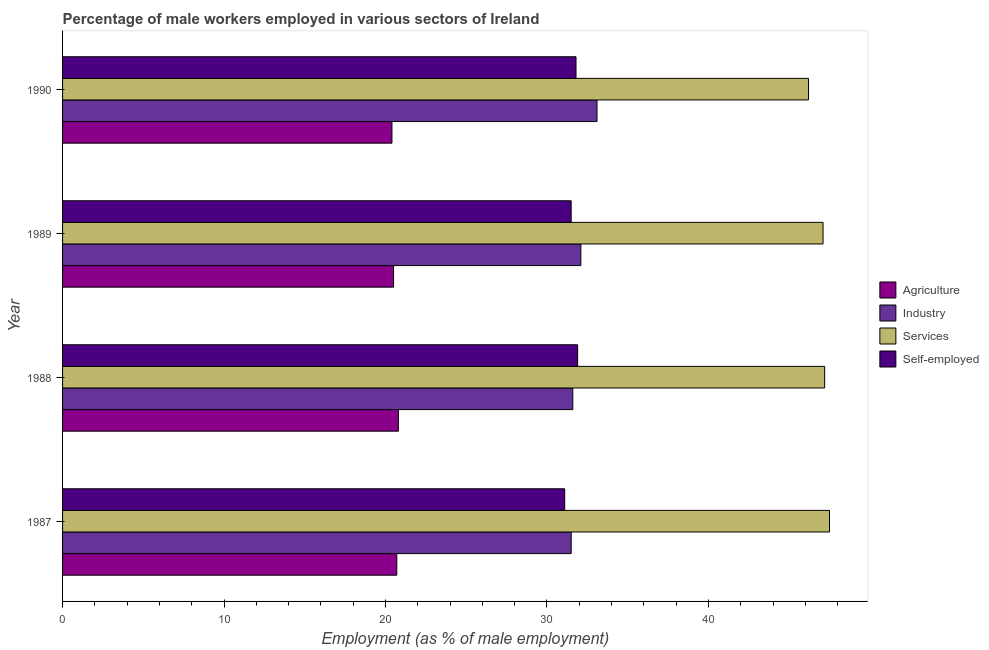How many different coloured bars are there?
Ensure brevity in your answer.  4. How many groups of bars are there?
Your answer should be very brief. 4. Are the number of bars per tick equal to the number of legend labels?
Your answer should be very brief. Yes. Are the number of bars on each tick of the Y-axis equal?
Keep it short and to the point. Yes. How many bars are there on the 3rd tick from the top?
Provide a succinct answer. 4. How many bars are there on the 4th tick from the bottom?
Your response must be concise. 4. What is the percentage of male workers in industry in 1988?
Keep it short and to the point. 31.6. Across all years, what is the maximum percentage of self employed male workers?
Give a very brief answer. 31.9. Across all years, what is the minimum percentage of male workers in services?
Your answer should be compact. 46.2. What is the total percentage of male workers in industry in the graph?
Your answer should be very brief. 128.3. What is the difference between the percentage of self employed male workers in 1990 and the percentage of male workers in agriculture in 1989?
Your response must be concise. 11.3. What is the average percentage of male workers in agriculture per year?
Your response must be concise. 20.6. What is the ratio of the percentage of male workers in agriculture in 1988 to that in 1990?
Provide a short and direct response. 1.02. Is the percentage of male workers in services in 1987 less than that in 1990?
Your answer should be very brief. No. Is the difference between the percentage of male workers in services in 1988 and 1990 greater than the difference between the percentage of male workers in industry in 1988 and 1990?
Give a very brief answer. Yes. What is the difference between the highest and the second highest percentage of male workers in industry?
Offer a very short reply. 1. In how many years, is the percentage of male workers in agriculture greater than the average percentage of male workers in agriculture taken over all years?
Your answer should be very brief. 2. What does the 1st bar from the top in 1990 represents?
Give a very brief answer. Self-employed. What does the 1st bar from the bottom in 1989 represents?
Keep it short and to the point. Agriculture. How many bars are there?
Offer a terse response. 16. Are all the bars in the graph horizontal?
Your response must be concise. Yes. What is the difference between two consecutive major ticks on the X-axis?
Offer a terse response. 10. Does the graph contain grids?
Your answer should be very brief. No. How many legend labels are there?
Offer a very short reply. 4. What is the title of the graph?
Provide a short and direct response. Percentage of male workers employed in various sectors of Ireland. What is the label or title of the X-axis?
Keep it short and to the point. Employment (as % of male employment). What is the Employment (as % of male employment) in Agriculture in 1987?
Make the answer very short. 20.7. What is the Employment (as % of male employment) in Industry in 1987?
Your response must be concise. 31.5. What is the Employment (as % of male employment) of Services in 1987?
Provide a short and direct response. 47.5. What is the Employment (as % of male employment) of Self-employed in 1987?
Offer a terse response. 31.1. What is the Employment (as % of male employment) in Agriculture in 1988?
Ensure brevity in your answer.  20.8. What is the Employment (as % of male employment) of Industry in 1988?
Provide a succinct answer. 31.6. What is the Employment (as % of male employment) in Services in 1988?
Offer a terse response. 47.2. What is the Employment (as % of male employment) in Self-employed in 1988?
Provide a short and direct response. 31.9. What is the Employment (as % of male employment) in Industry in 1989?
Ensure brevity in your answer.  32.1. What is the Employment (as % of male employment) in Services in 1989?
Ensure brevity in your answer.  47.1. What is the Employment (as % of male employment) of Self-employed in 1989?
Ensure brevity in your answer.  31.5. What is the Employment (as % of male employment) in Agriculture in 1990?
Offer a terse response. 20.4. What is the Employment (as % of male employment) in Industry in 1990?
Your answer should be very brief. 33.1. What is the Employment (as % of male employment) in Services in 1990?
Your answer should be very brief. 46.2. What is the Employment (as % of male employment) in Self-employed in 1990?
Your answer should be very brief. 31.8. Across all years, what is the maximum Employment (as % of male employment) in Agriculture?
Provide a succinct answer. 20.8. Across all years, what is the maximum Employment (as % of male employment) of Industry?
Give a very brief answer. 33.1. Across all years, what is the maximum Employment (as % of male employment) of Services?
Provide a succinct answer. 47.5. Across all years, what is the maximum Employment (as % of male employment) of Self-employed?
Your answer should be very brief. 31.9. Across all years, what is the minimum Employment (as % of male employment) in Agriculture?
Give a very brief answer. 20.4. Across all years, what is the minimum Employment (as % of male employment) of Industry?
Provide a short and direct response. 31.5. Across all years, what is the minimum Employment (as % of male employment) of Services?
Your answer should be compact. 46.2. Across all years, what is the minimum Employment (as % of male employment) in Self-employed?
Offer a very short reply. 31.1. What is the total Employment (as % of male employment) of Agriculture in the graph?
Your answer should be compact. 82.4. What is the total Employment (as % of male employment) in Industry in the graph?
Offer a very short reply. 128.3. What is the total Employment (as % of male employment) in Services in the graph?
Give a very brief answer. 188. What is the total Employment (as % of male employment) in Self-employed in the graph?
Give a very brief answer. 126.3. What is the difference between the Employment (as % of male employment) in Industry in 1987 and that in 1988?
Offer a very short reply. -0.1. What is the difference between the Employment (as % of male employment) of Self-employed in 1987 and that in 1988?
Provide a short and direct response. -0.8. What is the difference between the Employment (as % of male employment) in Agriculture in 1987 and that in 1989?
Provide a short and direct response. 0.2. What is the difference between the Employment (as % of male employment) of Self-employed in 1987 and that in 1989?
Your response must be concise. -0.4. What is the difference between the Employment (as % of male employment) of Industry in 1987 and that in 1990?
Make the answer very short. -1.6. What is the difference between the Employment (as % of male employment) of Services in 1987 and that in 1990?
Make the answer very short. 1.3. What is the difference between the Employment (as % of male employment) in Agriculture in 1988 and that in 1989?
Make the answer very short. 0.3. What is the difference between the Employment (as % of male employment) in Services in 1988 and that in 1989?
Your response must be concise. 0.1. What is the difference between the Employment (as % of male employment) of Self-employed in 1988 and that in 1989?
Your response must be concise. 0.4. What is the difference between the Employment (as % of male employment) of Industry in 1988 and that in 1990?
Provide a succinct answer. -1.5. What is the difference between the Employment (as % of male employment) in Services in 1988 and that in 1990?
Your response must be concise. 1. What is the difference between the Employment (as % of male employment) of Industry in 1989 and that in 1990?
Give a very brief answer. -1. What is the difference between the Employment (as % of male employment) in Services in 1989 and that in 1990?
Keep it short and to the point. 0.9. What is the difference between the Employment (as % of male employment) in Agriculture in 1987 and the Employment (as % of male employment) in Industry in 1988?
Offer a terse response. -10.9. What is the difference between the Employment (as % of male employment) in Agriculture in 1987 and the Employment (as % of male employment) in Services in 1988?
Your answer should be very brief. -26.5. What is the difference between the Employment (as % of male employment) in Industry in 1987 and the Employment (as % of male employment) in Services in 1988?
Keep it short and to the point. -15.7. What is the difference between the Employment (as % of male employment) of Agriculture in 1987 and the Employment (as % of male employment) of Industry in 1989?
Give a very brief answer. -11.4. What is the difference between the Employment (as % of male employment) of Agriculture in 1987 and the Employment (as % of male employment) of Services in 1989?
Your answer should be compact. -26.4. What is the difference between the Employment (as % of male employment) in Agriculture in 1987 and the Employment (as % of male employment) in Self-employed in 1989?
Your answer should be very brief. -10.8. What is the difference between the Employment (as % of male employment) of Industry in 1987 and the Employment (as % of male employment) of Services in 1989?
Your answer should be very brief. -15.6. What is the difference between the Employment (as % of male employment) in Services in 1987 and the Employment (as % of male employment) in Self-employed in 1989?
Make the answer very short. 16. What is the difference between the Employment (as % of male employment) in Agriculture in 1987 and the Employment (as % of male employment) in Services in 1990?
Give a very brief answer. -25.5. What is the difference between the Employment (as % of male employment) in Industry in 1987 and the Employment (as % of male employment) in Services in 1990?
Make the answer very short. -14.7. What is the difference between the Employment (as % of male employment) of Agriculture in 1988 and the Employment (as % of male employment) of Industry in 1989?
Offer a terse response. -11.3. What is the difference between the Employment (as % of male employment) of Agriculture in 1988 and the Employment (as % of male employment) of Services in 1989?
Ensure brevity in your answer.  -26.3. What is the difference between the Employment (as % of male employment) of Agriculture in 1988 and the Employment (as % of male employment) of Self-employed in 1989?
Your response must be concise. -10.7. What is the difference between the Employment (as % of male employment) in Industry in 1988 and the Employment (as % of male employment) in Services in 1989?
Your response must be concise. -15.5. What is the difference between the Employment (as % of male employment) of Industry in 1988 and the Employment (as % of male employment) of Self-employed in 1989?
Offer a terse response. 0.1. What is the difference between the Employment (as % of male employment) of Services in 1988 and the Employment (as % of male employment) of Self-employed in 1989?
Your answer should be very brief. 15.7. What is the difference between the Employment (as % of male employment) of Agriculture in 1988 and the Employment (as % of male employment) of Industry in 1990?
Your answer should be compact. -12.3. What is the difference between the Employment (as % of male employment) of Agriculture in 1988 and the Employment (as % of male employment) of Services in 1990?
Your answer should be compact. -25.4. What is the difference between the Employment (as % of male employment) in Agriculture in 1988 and the Employment (as % of male employment) in Self-employed in 1990?
Provide a short and direct response. -11. What is the difference between the Employment (as % of male employment) in Industry in 1988 and the Employment (as % of male employment) in Services in 1990?
Offer a very short reply. -14.6. What is the difference between the Employment (as % of male employment) of Services in 1988 and the Employment (as % of male employment) of Self-employed in 1990?
Ensure brevity in your answer.  15.4. What is the difference between the Employment (as % of male employment) in Agriculture in 1989 and the Employment (as % of male employment) in Industry in 1990?
Give a very brief answer. -12.6. What is the difference between the Employment (as % of male employment) of Agriculture in 1989 and the Employment (as % of male employment) of Services in 1990?
Offer a terse response. -25.7. What is the difference between the Employment (as % of male employment) of Industry in 1989 and the Employment (as % of male employment) of Services in 1990?
Your answer should be compact. -14.1. What is the difference between the Employment (as % of male employment) of Industry in 1989 and the Employment (as % of male employment) of Self-employed in 1990?
Provide a succinct answer. 0.3. What is the average Employment (as % of male employment) in Agriculture per year?
Make the answer very short. 20.6. What is the average Employment (as % of male employment) of Industry per year?
Keep it short and to the point. 32.08. What is the average Employment (as % of male employment) in Self-employed per year?
Your answer should be compact. 31.57. In the year 1987, what is the difference between the Employment (as % of male employment) in Agriculture and Employment (as % of male employment) in Services?
Your answer should be compact. -26.8. In the year 1987, what is the difference between the Employment (as % of male employment) in Industry and Employment (as % of male employment) in Self-employed?
Your response must be concise. 0.4. In the year 1987, what is the difference between the Employment (as % of male employment) of Services and Employment (as % of male employment) of Self-employed?
Provide a succinct answer. 16.4. In the year 1988, what is the difference between the Employment (as % of male employment) of Agriculture and Employment (as % of male employment) of Services?
Provide a succinct answer. -26.4. In the year 1988, what is the difference between the Employment (as % of male employment) in Agriculture and Employment (as % of male employment) in Self-employed?
Keep it short and to the point. -11.1. In the year 1988, what is the difference between the Employment (as % of male employment) in Industry and Employment (as % of male employment) in Services?
Provide a short and direct response. -15.6. In the year 1988, what is the difference between the Employment (as % of male employment) of Industry and Employment (as % of male employment) of Self-employed?
Make the answer very short. -0.3. In the year 1989, what is the difference between the Employment (as % of male employment) of Agriculture and Employment (as % of male employment) of Industry?
Provide a short and direct response. -11.6. In the year 1989, what is the difference between the Employment (as % of male employment) of Agriculture and Employment (as % of male employment) of Services?
Your answer should be compact. -26.6. In the year 1989, what is the difference between the Employment (as % of male employment) in Agriculture and Employment (as % of male employment) in Self-employed?
Give a very brief answer. -11. In the year 1989, what is the difference between the Employment (as % of male employment) of Industry and Employment (as % of male employment) of Services?
Offer a very short reply. -15. In the year 1990, what is the difference between the Employment (as % of male employment) of Agriculture and Employment (as % of male employment) of Services?
Give a very brief answer. -25.8. In the year 1990, what is the difference between the Employment (as % of male employment) in Industry and Employment (as % of male employment) in Services?
Ensure brevity in your answer.  -13.1. What is the ratio of the Employment (as % of male employment) in Agriculture in 1987 to that in 1988?
Ensure brevity in your answer.  1. What is the ratio of the Employment (as % of male employment) of Industry in 1987 to that in 1988?
Keep it short and to the point. 1. What is the ratio of the Employment (as % of male employment) in Services in 1987 to that in 1988?
Make the answer very short. 1.01. What is the ratio of the Employment (as % of male employment) in Self-employed in 1987 to that in 1988?
Your answer should be compact. 0.97. What is the ratio of the Employment (as % of male employment) in Agriculture in 1987 to that in 1989?
Give a very brief answer. 1.01. What is the ratio of the Employment (as % of male employment) in Industry in 1987 to that in 1989?
Provide a succinct answer. 0.98. What is the ratio of the Employment (as % of male employment) of Services in 1987 to that in 1989?
Your answer should be compact. 1.01. What is the ratio of the Employment (as % of male employment) of Self-employed in 1987 to that in 1989?
Your response must be concise. 0.99. What is the ratio of the Employment (as % of male employment) of Agriculture in 1987 to that in 1990?
Your answer should be compact. 1.01. What is the ratio of the Employment (as % of male employment) of Industry in 1987 to that in 1990?
Offer a very short reply. 0.95. What is the ratio of the Employment (as % of male employment) of Services in 1987 to that in 1990?
Make the answer very short. 1.03. What is the ratio of the Employment (as % of male employment) in Self-employed in 1987 to that in 1990?
Make the answer very short. 0.98. What is the ratio of the Employment (as % of male employment) of Agriculture in 1988 to that in 1989?
Give a very brief answer. 1.01. What is the ratio of the Employment (as % of male employment) of Industry in 1988 to that in 1989?
Make the answer very short. 0.98. What is the ratio of the Employment (as % of male employment) of Services in 1988 to that in 1989?
Your answer should be very brief. 1. What is the ratio of the Employment (as % of male employment) of Self-employed in 1988 to that in 1989?
Keep it short and to the point. 1.01. What is the ratio of the Employment (as % of male employment) of Agriculture in 1988 to that in 1990?
Your response must be concise. 1.02. What is the ratio of the Employment (as % of male employment) in Industry in 1988 to that in 1990?
Your answer should be compact. 0.95. What is the ratio of the Employment (as % of male employment) of Services in 1988 to that in 1990?
Make the answer very short. 1.02. What is the ratio of the Employment (as % of male employment) in Agriculture in 1989 to that in 1990?
Give a very brief answer. 1. What is the ratio of the Employment (as % of male employment) of Industry in 1989 to that in 1990?
Your answer should be very brief. 0.97. What is the ratio of the Employment (as % of male employment) in Services in 1989 to that in 1990?
Offer a very short reply. 1.02. What is the ratio of the Employment (as % of male employment) in Self-employed in 1989 to that in 1990?
Make the answer very short. 0.99. What is the difference between the highest and the second highest Employment (as % of male employment) of Agriculture?
Make the answer very short. 0.1. What is the difference between the highest and the lowest Employment (as % of male employment) in Agriculture?
Provide a succinct answer. 0.4. What is the difference between the highest and the lowest Employment (as % of male employment) of Industry?
Keep it short and to the point. 1.6. What is the difference between the highest and the lowest Employment (as % of male employment) in Services?
Keep it short and to the point. 1.3. What is the difference between the highest and the lowest Employment (as % of male employment) of Self-employed?
Give a very brief answer. 0.8. 